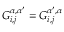Convert formula to latex. <formula><loc_0><loc_0><loc_500><loc_500>G _ { i , j } ^ { \alpha , \alpha ^ { \prime } } = G _ { i , j } ^ { \alpha ^ { \prime } , \alpha }</formula> 